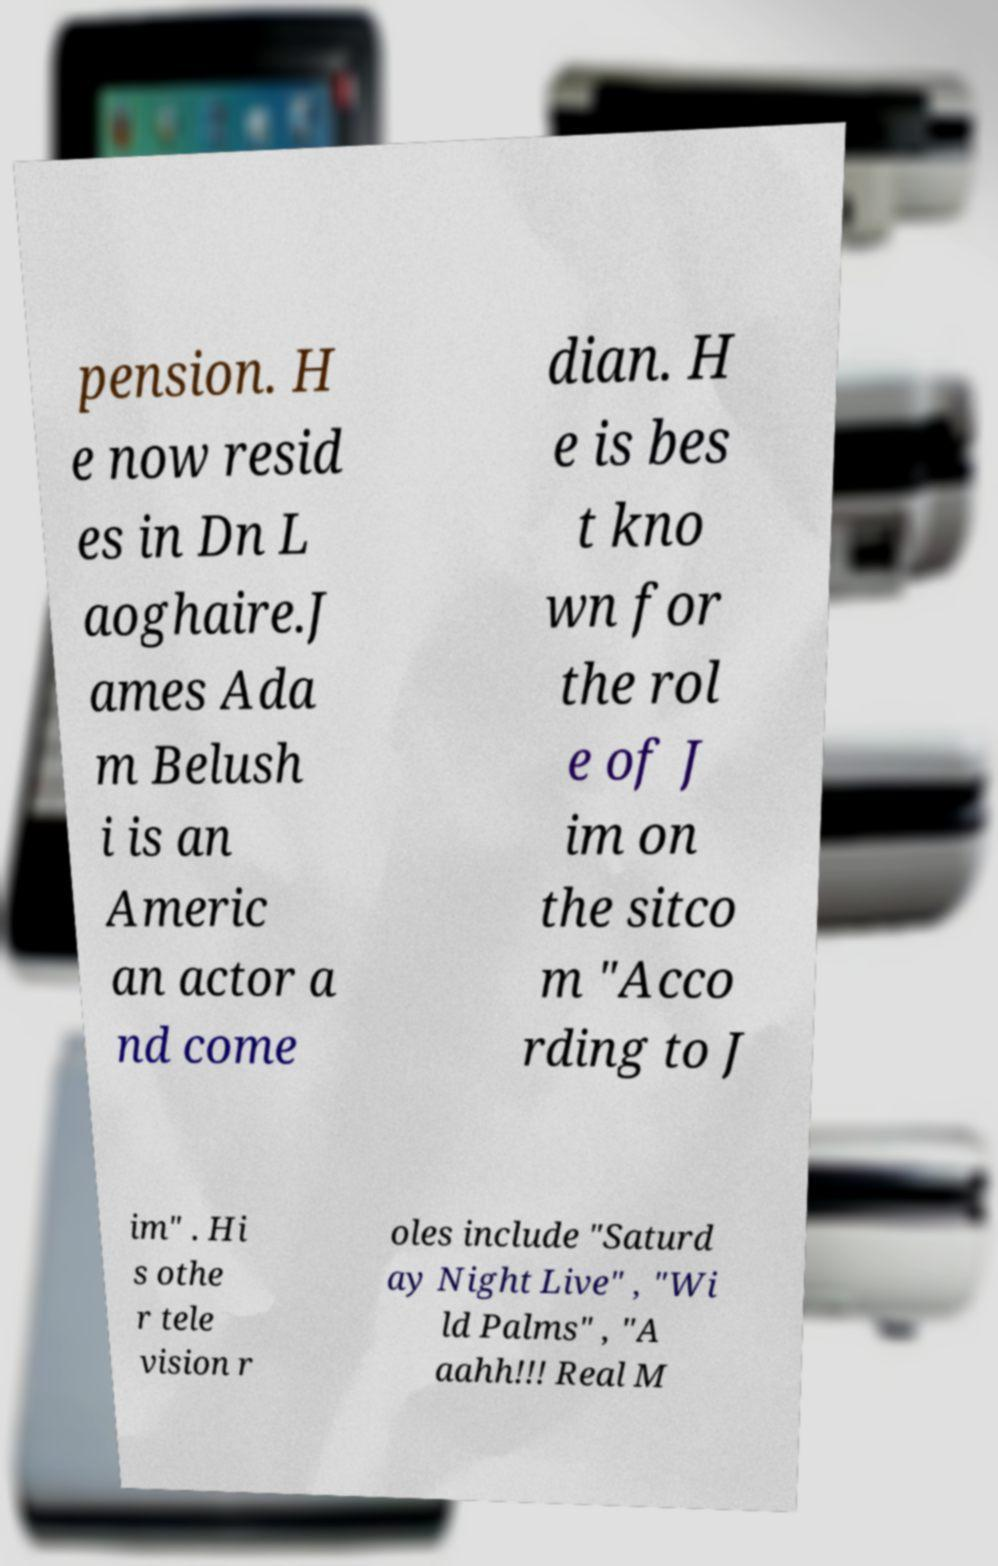Can you accurately transcribe the text from the provided image for me? pension. H e now resid es in Dn L aoghaire.J ames Ada m Belush i is an Americ an actor a nd come dian. H e is bes t kno wn for the rol e of J im on the sitco m "Acco rding to J im" . Hi s othe r tele vision r oles include "Saturd ay Night Live" , "Wi ld Palms" , "A aahh!!! Real M 